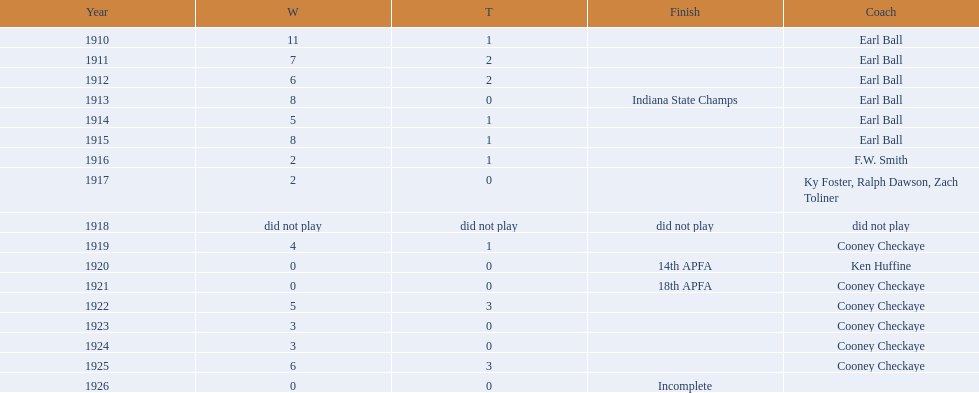Parse the full table. {'header': ['Year', 'W', 'T', 'Finish', 'Coach'], 'rows': [['1910', '11', '1', '', 'Earl Ball'], ['1911', '7', '2', '', 'Earl Ball'], ['1912', '6', '2', '', 'Earl Ball'], ['1913', '8', '0', 'Indiana State Champs', 'Earl Ball'], ['1914', '5', '1', '', 'Earl Ball'], ['1915', '8', '1', '', 'Earl Ball'], ['1916', '2', '1', '', 'F.W. Smith'], ['1917', '2', '0', '', 'Ky Foster, Ralph Dawson, Zach Toliner'], ['1918', 'did not play', 'did not play', 'did not play', 'did not play'], ['1919', '4', '1', '', 'Cooney Checkaye'], ['1920', '0', '0', '14th APFA', 'Ken Huffine'], ['1921', '0', '0', '18th APFA', 'Cooney Checkaye'], ['1922', '5', '3', '', 'Cooney Checkaye'], ['1923', '3', '0', '', 'Cooney Checkaye'], ['1924', '3', '0', '', 'Cooney Checkaye'], ['1925', '6', '3', '', 'Cooney Checkaye'], ['1926', '0', '0', 'Incomplete', '']]} During the period from 1910 to 1925, the muncie flyers were active in all years except one. which year was that? 1918. 